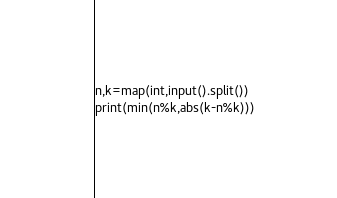<code> <loc_0><loc_0><loc_500><loc_500><_Python_>n,k=map(int,input().split())
print(min(n%k,abs(k-n%k)))</code> 